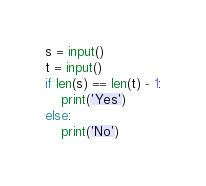<code> <loc_0><loc_0><loc_500><loc_500><_Python_>s = input()
t = input()
if len(s) == len(t) - 1:
    print('Yes')
else:
    print('No')</code> 